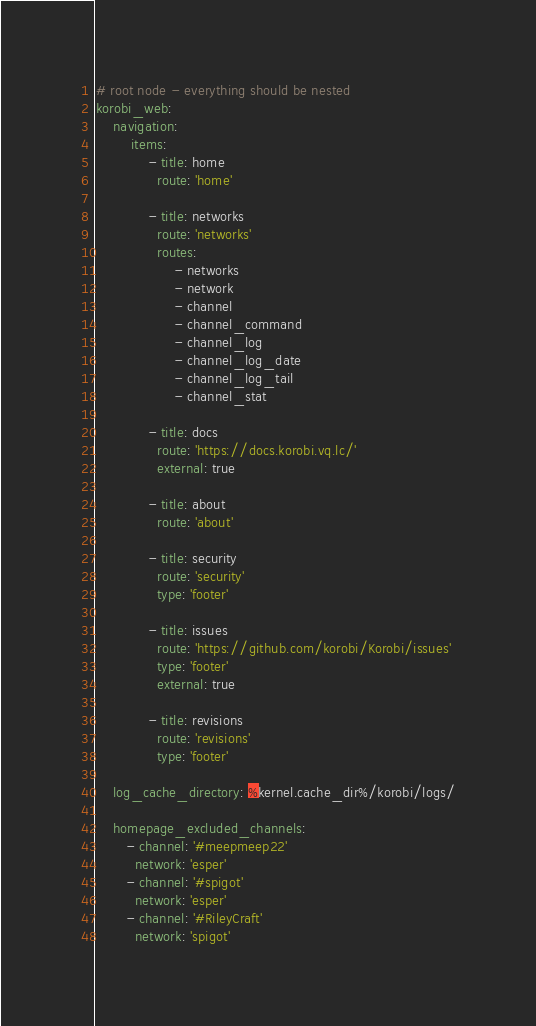<code> <loc_0><loc_0><loc_500><loc_500><_YAML_># root node - everything should be nested
korobi_web:
    navigation:
        items:
            - title: home
              route: 'home'

            - title: networks
              route: 'networks'
              routes:
                  - networks
                  - network
                  - channel
                  - channel_command
                  - channel_log
                  - channel_log_date
                  - channel_log_tail
                  - channel_stat

            - title: docs
              route: 'https://docs.korobi.vq.lc/'
              external: true

            - title: about
              route: 'about'

            - title: security
              route: 'security'
              type: 'footer'

            - title: issues
              route: 'https://github.com/korobi/Korobi/issues'
              type: 'footer'
              external: true

            - title: revisions
              route: 'revisions'
              type: 'footer'

    log_cache_directory: %kernel.cache_dir%/korobi/logs/

    homepage_excluded_channels:
       - channel: '#meepmeep22'
         network: 'esper'
       - channel: '#spigot'
         network: 'esper'
       - channel: '#RileyCraft'
         network: 'spigot'
</code> 